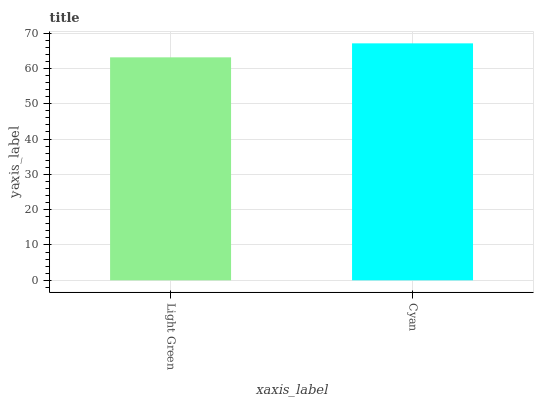Is Light Green the minimum?
Answer yes or no. Yes. Is Cyan the maximum?
Answer yes or no. Yes. Is Cyan the minimum?
Answer yes or no. No. Is Cyan greater than Light Green?
Answer yes or no. Yes. Is Light Green less than Cyan?
Answer yes or no. Yes. Is Light Green greater than Cyan?
Answer yes or no. No. Is Cyan less than Light Green?
Answer yes or no. No. Is Cyan the high median?
Answer yes or no. Yes. Is Light Green the low median?
Answer yes or no. Yes. Is Light Green the high median?
Answer yes or no. No. Is Cyan the low median?
Answer yes or no. No. 